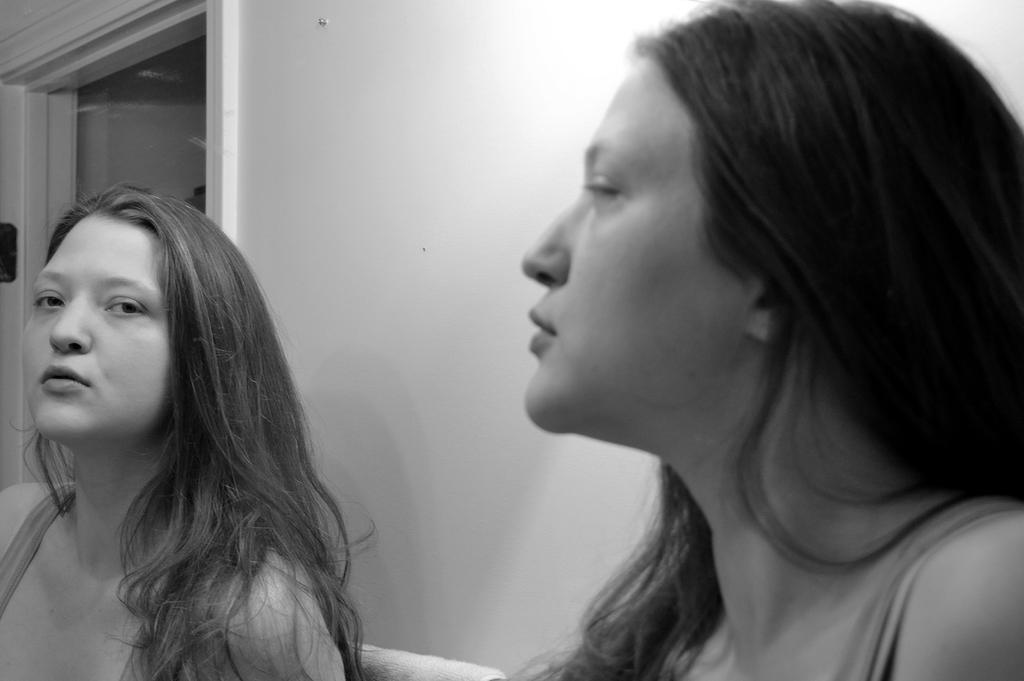What is the color scheme of the image? The image is black and white. Who is present in the image? There is a woman in the image. What is the woman doing in the image? The woman is looking into a mirror. What type of cracker is the woman holding in the image? There is no cracker present in the image; the woman is looking into a mirror. How many pages are visible in the image? There are no pages present in the image; it is a black and white image of a woman looking into a mirror. 